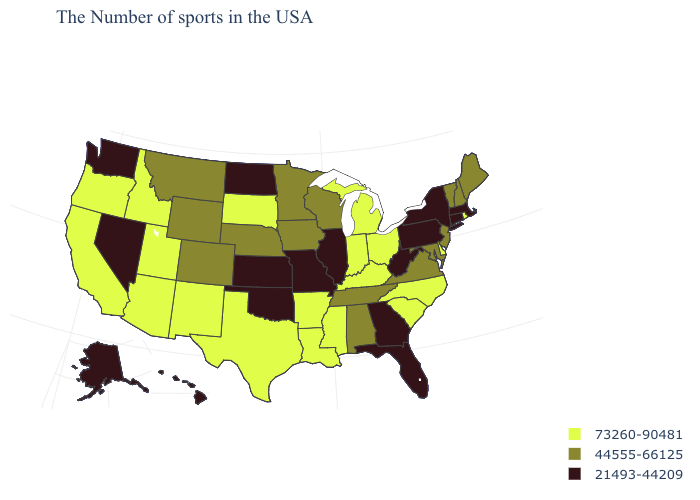Among the states that border West Virginia , which have the highest value?
Answer briefly. Ohio, Kentucky. What is the value of Virginia?
Write a very short answer. 44555-66125. Which states have the lowest value in the South?
Answer briefly. West Virginia, Florida, Georgia, Oklahoma. What is the highest value in the West ?
Answer briefly. 73260-90481. What is the value of West Virginia?
Concise answer only. 21493-44209. What is the value of South Dakota?
Short answer required. 73260-90481. Does Georgia have the same value as Oklahoma?
Quick response, please. Yes. What is the highest value in the MidWest ?
Quick response, please. 73260-90481. Name the states that have a value in the range 21493-44209?
Be succinct. Massachusetts, Connecticut, New York, Pennsylvania, West Virginia, Florida, Georgia, Illinois, Missouri, Kansas, Oklahoma, North Dakota, Nevada, Washington, Alaska, Hawaii. Among the states that border Virginia , does West Virginia have the lowest value?
Concise answer only. Yes. Name the states that have a value in the range 21493-44209?
Keep it brief. Massachusetts, Connecticut, New York, Pennsylvania, West Virginia, Florida, Georgia, Illinois, Missouri, Kansas, Oklahoma, North Dakota, Nevada, Washington, Alaska, Hawaii. Does Arizona have the same value as Oklahoma?
Keep it brief. No. Does New York have a lower value than Michigan?
Short answer required. Yes. What is the value of Delaware?
Quick response, please. 73260-90481. Among the states that border Tennessee , which have the highest value?
Quick response, please. North Carolina, Kentucky, Mississippi, Arkansas. 